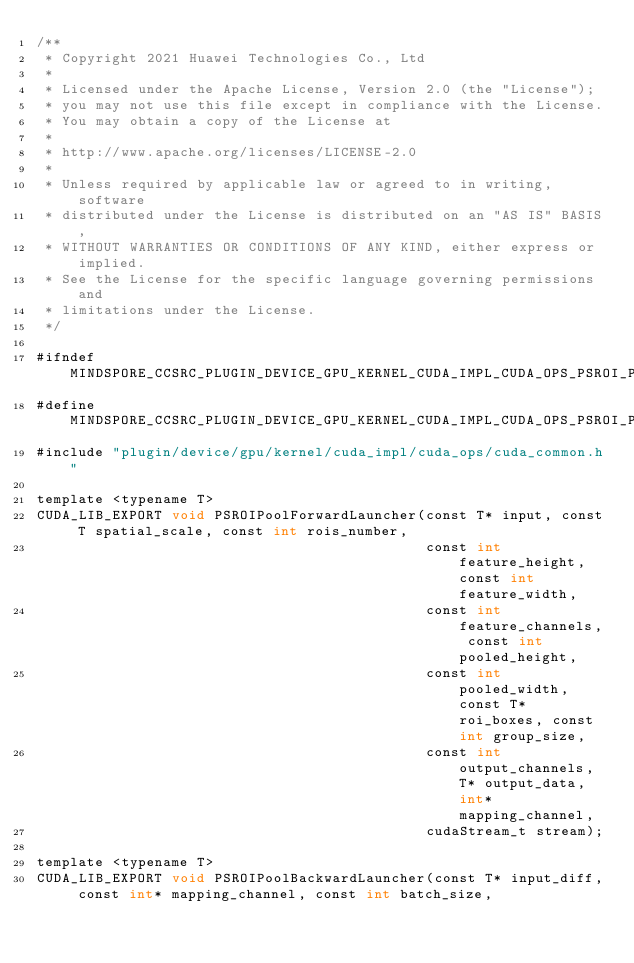<code> <loc_0><loc_0><loc_500><loc_500><_Cuda_>/**
 * Copyright 2021 Huawei Technologies Co., Ltd
 *
 * Licensed under the Apache License, Version 2.0 (the "License");
 * you may not use this file except in compliance with the License.
 * You may obtain a copy of the License at
 *
 * http://www.apache.org/licenses/LICENSE-2.0
 *
 * Unless required by applicable law or agreed to in writing, software
 * distributed under the License is distributed on an "AS IS" BASIS,
 * WITHOUT WARRANTIES OR CONDITIONS OF ANY KIND, either express or implied.
 * See the License for the specific language governing permissions and
 * limitations under the License.
 */

#ifndef MINDSPORE_CCSRC_PLUGIN_DEVICE_GPU_KERNEL_CUDA_IMPL_CUDA_OPS_PSROI_POOLING_IMPL_CUH_
#define MINDSPORE_CCSRC_PLUGIN_DEVICE_GPU_KERNEL_CUDA_IMPL_CUDA_OPS_PSROI_POOLING_IMPL_CUH_
#include "plugin/device/gpu/kernel/cuda_impl/cuda_ops/cuda_common.h"

template <typename T>
CUDA_LIB_EXPORT void PSROIPoolForwardLauncher(const T* input, const T spatial_scale, const int rois_number,
                                              const int feature_height, const int feature_width,
                                              const int feature_channels, const int pooled_height,
                                              const int pooled_width, const T* roi_boxes, const int group_size,
                                              const int output_channels, T* output_data, int* mapping_channel,
                                              cudaStream_t stream);

template <typename T>
CUDA_LIB_EXPORT void PSROIPoolBackwardLauncher(const T* input_diff, const int* mapping_channel, const int batch_size,</code> 